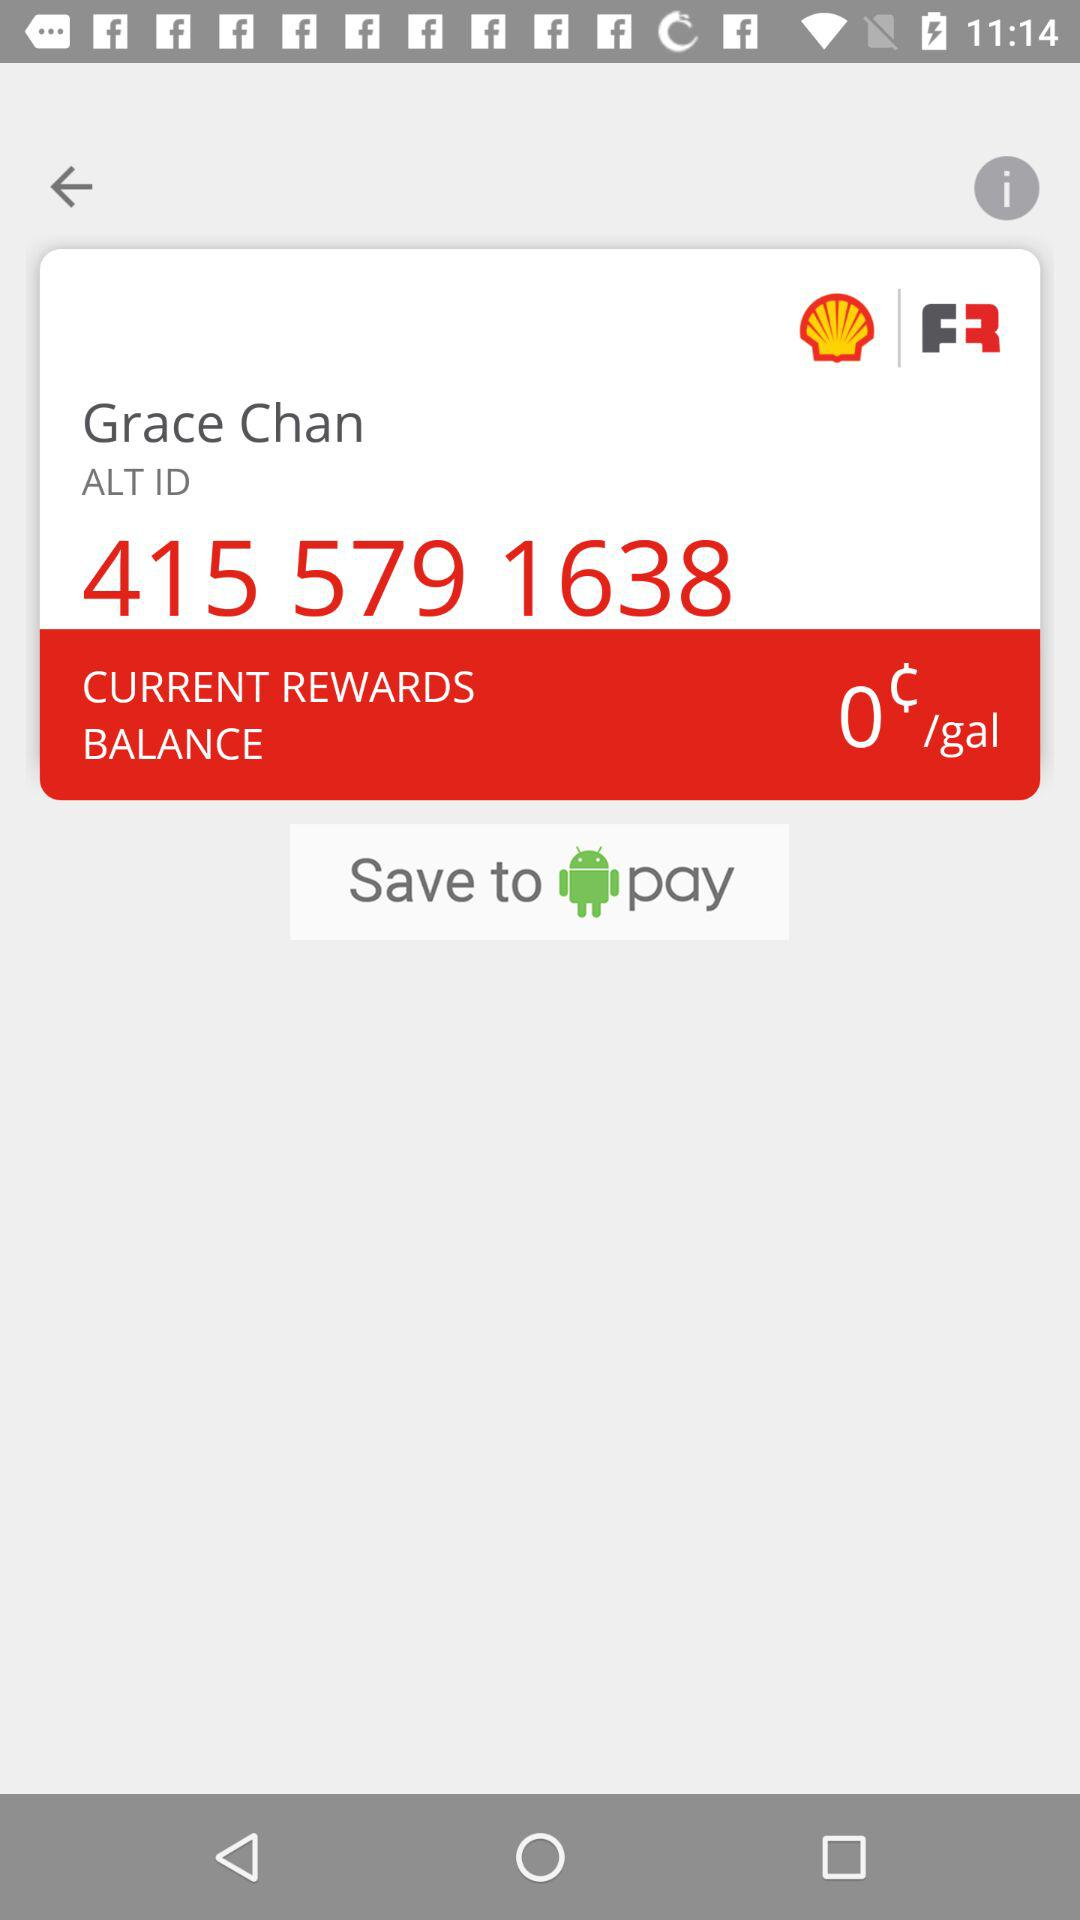What is the name of the user? The name of the user is Grace Chan. 